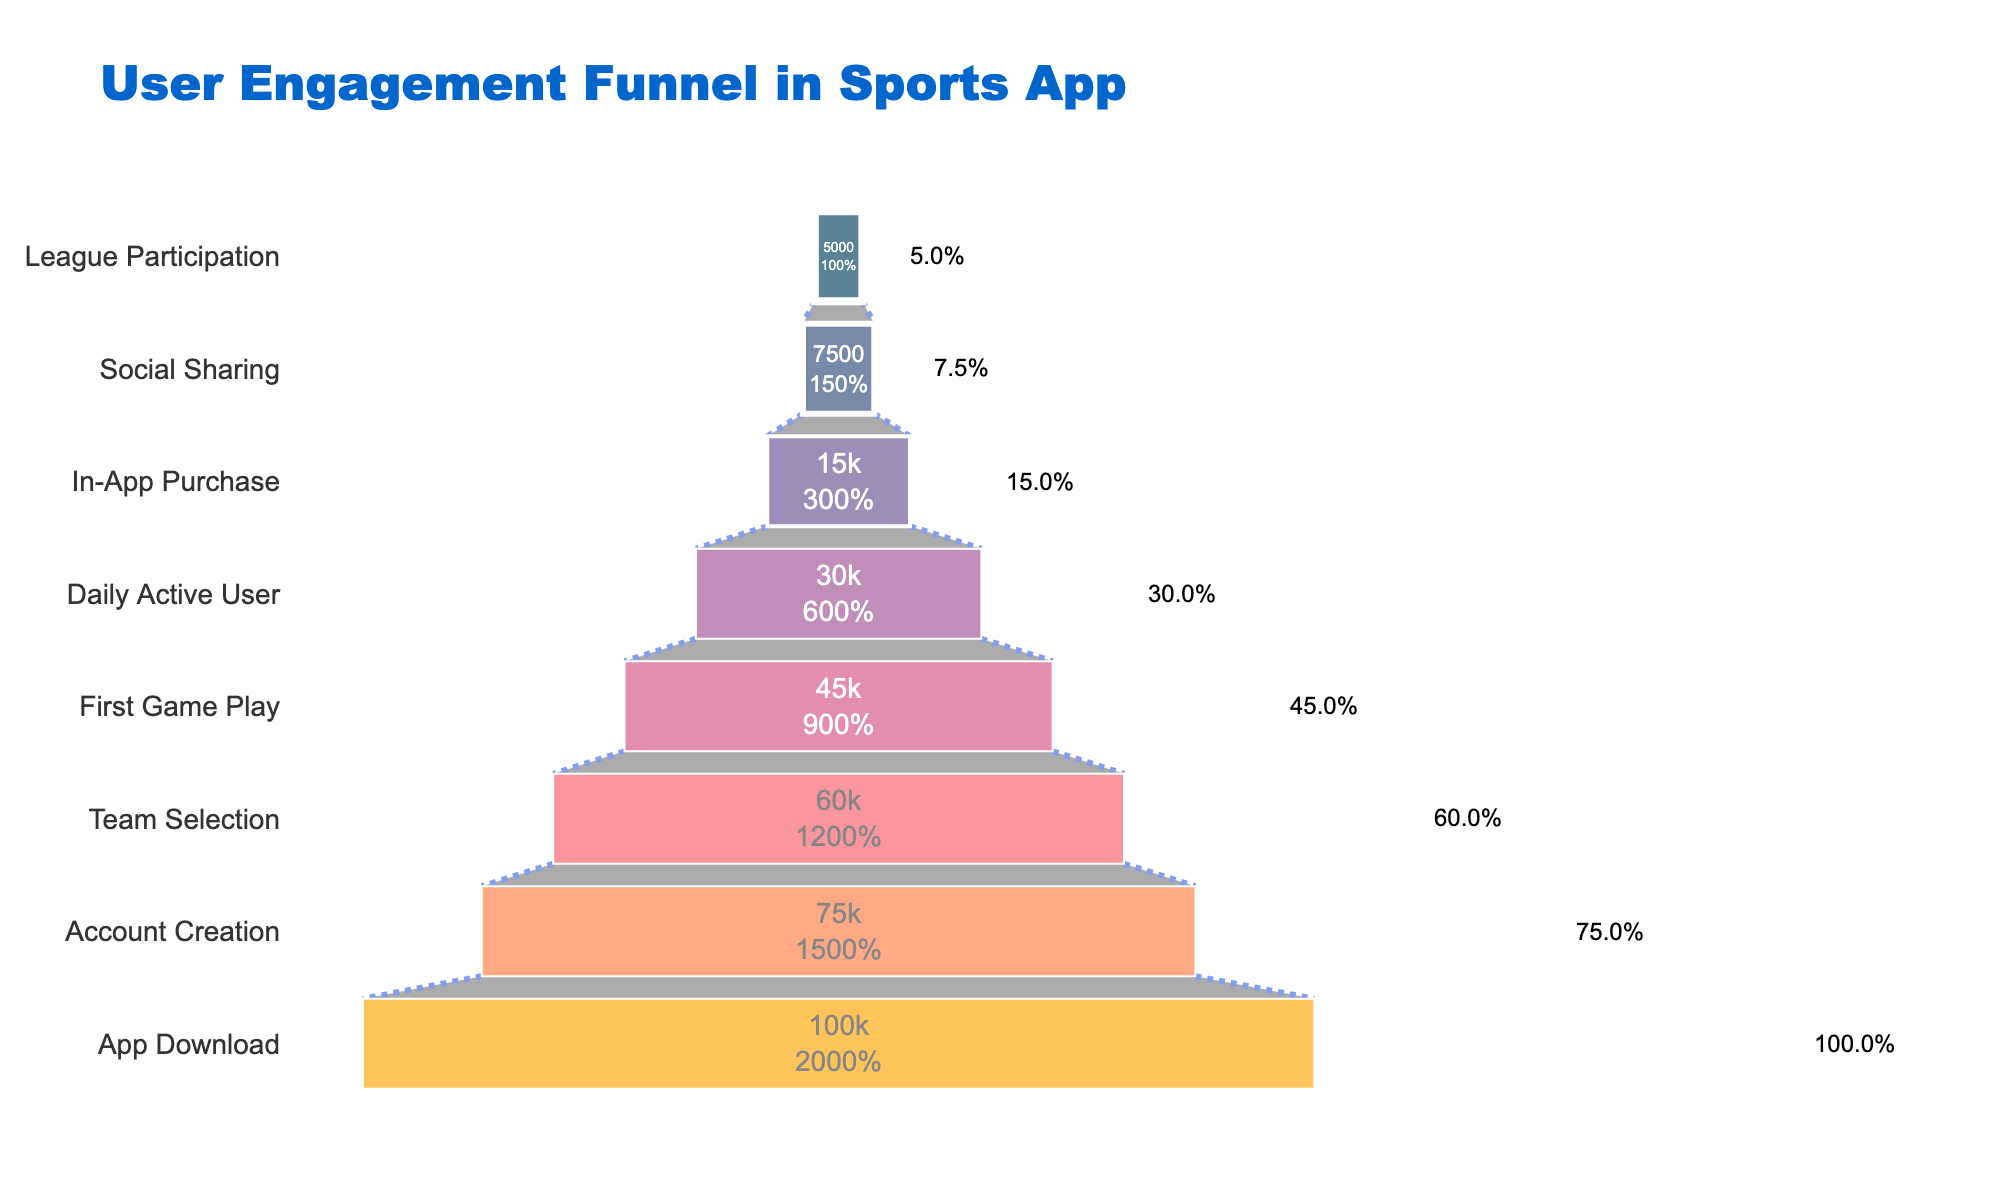What stage has the highest number of users? The title indicates that the chart shows a user engagement funnel for a sports app. The highest number of users corresponds to the first stage at the top of the funnel. By looking at the chart, we can see that "App Download" has the highest value of 100,000 users.
Answer: App Download What percentage of users progress from App Download to Account Creation? First, identify the number of users at both stages: App Download has 100,000 users, and Account Creation has 75,000 users. The percentage is calculated as (75,000 / 100,000) * 100%.
Answer: 75% How many users drop off between Team Selection and First Game Play? Team Selection has 60,000 users, and First Game Play has 45,000 users. The number of users who drop off is found by subtracting the value for First Game Play from Team Selection: 60,000 - 45,000.
Answer: 15,000 What stage has half the number of users compared to the First Game Play stage? First Game Play has 45,000 users. Half of this number is 22,500. The closest stage with a similar user count in the funnel chart is In-App Purchase with 15,000 users.
Answer: In-App Purchase How many users make it from App Download all the way to League Participation? The number of users at League Participation is given as the user count at the final stage of the funnel, which is 5,000.
Answer: 5,000 Which stage sees the largest percentage drop in users from the previous stage? To determine this, calculate the percentage drop between each stage: (1 - (next stage / previous stage)) * 100%. The largest percentage drop occurs between Daily Active User (30,000 users) and In-App Purchase (15,000 users). The drop is calculated as (1 - (15,000 / 30,000)) * 100%.
Answer: Daily Active User to In-App Purchase What's the percentage of users who progress from First Game Play to Daily Active User? First Game Play has 45,000 users, and Daily Active User has 30,000. The percentage is calculated as (30,000 / 45,000) * 100%.
Answer: 66.7% How many stages have fewer than 10,000 users? Review the funnel chart and count the stages with fewer than 10,000 users: Social Sharing (7,500 users) and League Participation (5,000 users). There are two such stages.
Answer: 2 What is the cumulative number of users at the final three stages? Identify the number of users at the final three stages: In-App Purchase (15,000 users), Social Sharing (7,500 users), League Participation (5,000 users). Add them up: 15,000 + 7,500 + 5,000.
Answer: 27,500 